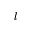Convert formula to latex. <formula><loc_0><loc_0><loc_500><loc_500>l</formula> 